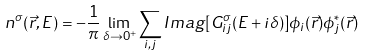Convert formula to latex. <formula><loc_0><loc_0><loc_500><loc_500>n ^ { \sigma } ( \vec { r } , E ) = - \frac { 1 } { \pi } \lim _ { \delta \to 0 ^ { + } } \sum _ { i , j } I m a g [ G _ { i j } ^ { \sigma } ( E + i \delta ) ] \phi _ { i } ( \vec { r } ) \phi _ { j } ^ { * } ( \vec { r } )</formula> 